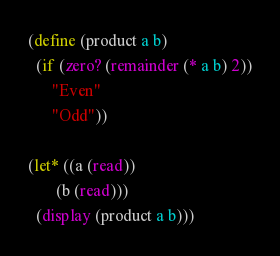Convert code to text. <code><loc_0><loc_0><loc_500><loc_500><_Scheme_>(define (product a b)
  (if (zero? (remainder (* a b) 2))
      "Even"
      "Odd"))

(let* ((a (read))
       (b (read)))
  (display (product a b)))
</code> 